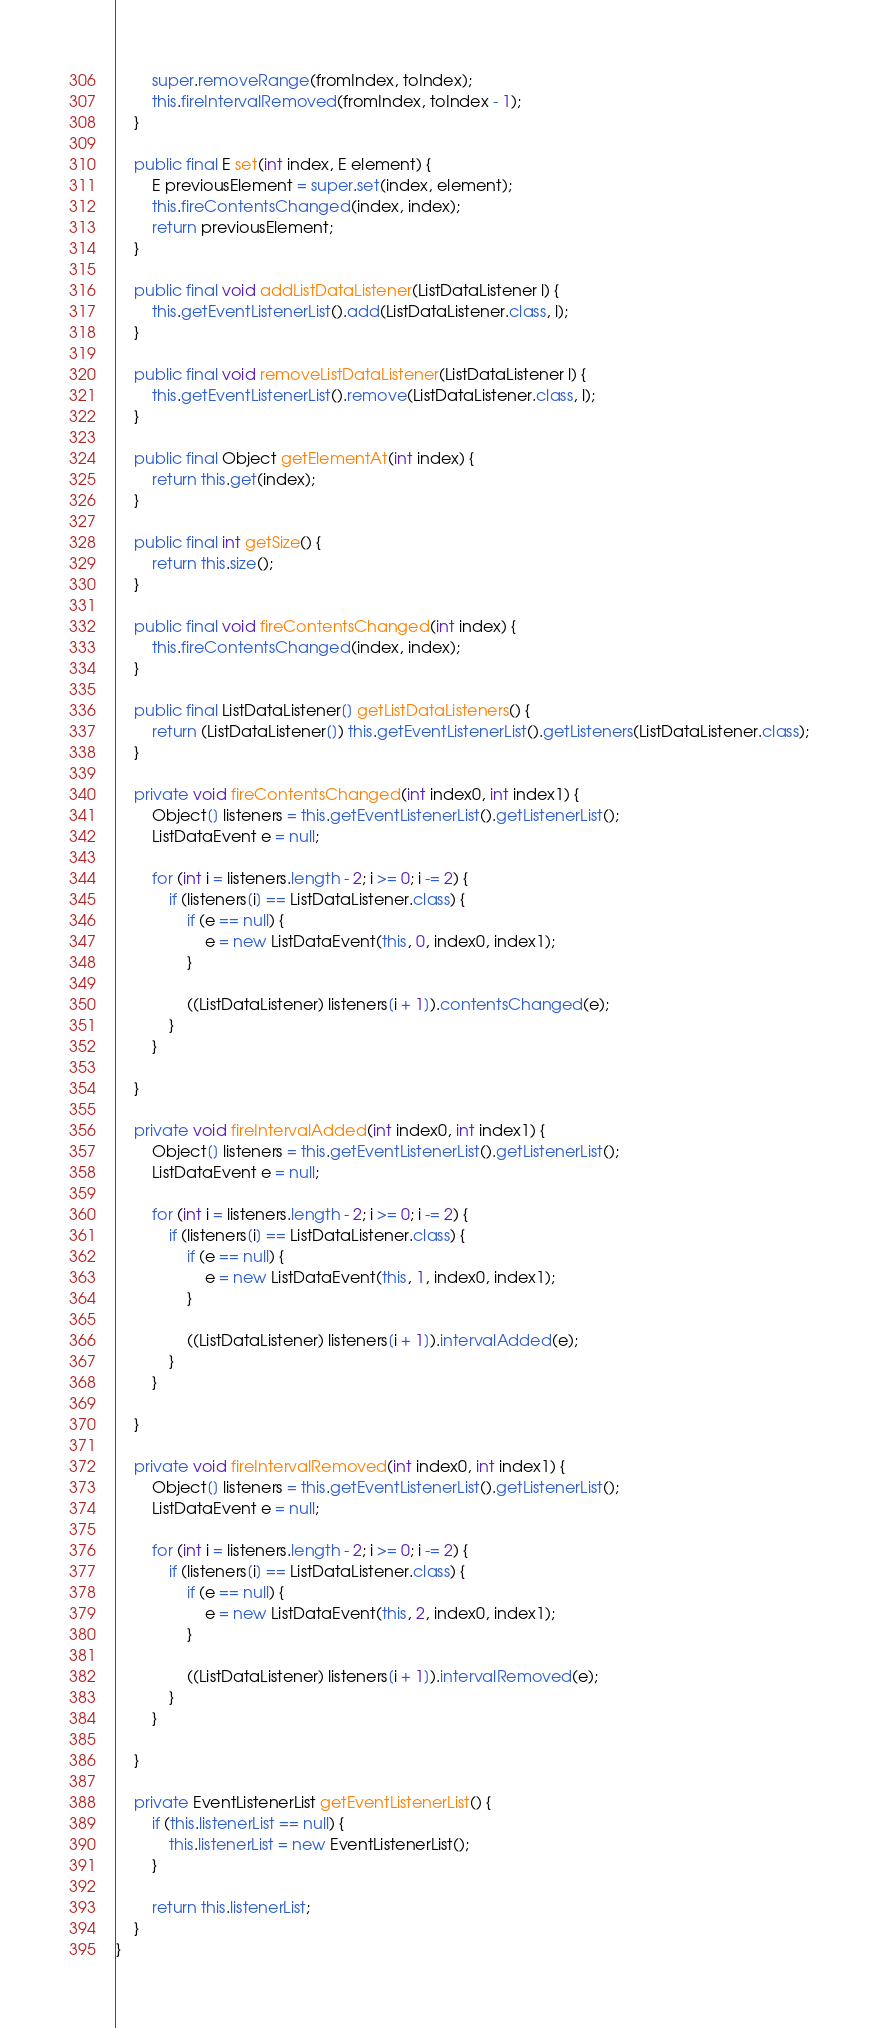<code> <loc_0><loc_0><loc_500><loc_500><_Java_>        super.removeRange(fromIndex, toIndex);
        this.fireIntervalRemoved(fromIndex, toIndex - 1);
    }

    public final E set(int index, E element) {
        E previousElement = super.set(index, element);
        this.fireContentsChanged(index, index);
        return previousElement;
    }

    public final void addListDataListener(ListDataListener l) {
        this.getEventListenerList().add(ListDataListener.class, l);
    }

    public final void removeListDataListener(ListDataListener l) {
        this.getEventListenerList().remove(ListDataListener.class, l);
    }

    public final Object getElementAt(int index) {
        return this.get(index);
    }

    public final int getSize() {
        return this.size();
    }

    public final void fireContentsChanged(int index) {
        this.fireContentsChanged(index, index);
    }

    public final ListDataListener[] getListDataListeners() {
        return (ListDataListener[]) this.getEventListenerList().getListeners(ListDataListener.class);
    }

    private void fireContentsChanged(int index0, int index1) {
        Object[] listeners = this.getEventListenerList().getListenerList();
        ListDataEvent e = null;

        for (int i = listeners.length - 2; i >= 0; i -= 2) {
            if (listeners[i] == ListDataListener.class) {
                if (e == null) {
                    e = new ListDataEvent(this, 0, index0, index1);
                }

                ((ListDataListener) listeners[i + 1]).contentsChanged(e);
            }
        }

    }

    private void fireIntervalAdded(int index0, int index1) {
        Object[] listeners = this.getEventListenerList().getListenerList();
        ListDataEvent e = null;

        for (int i = listeners.length - 2; i >= 0; i -= 2) {
            if (listeners[i] == ListDataListener.class) {
                if (e == null) {
                    e = new ListDataEvent(this, 1, index0, index1);
                }

                ((ListDataListener) listeners[i + 1]).intervalAdded(e);
            }
        }

    }

    private void fireIntervalRemoved(int index0, int index1) {
        Object[] listeners = this.getEventListenerList().getListenerList();
        ListDataEvent e = null;

        for (int i = listeners.length - 2; i >= 0; i -= 2) {
            if (listeners[i] == ListDataListener.class) {
                if (e == null) {
                    e = new ListDataEvent(this, 2, index0, index1);
                }

                ((ListDataListener) listeners[i + 1]).intervalRemoved(e);
            }
        }

    }

    private EventListenerList getEventListenerList() {
        if (this.listenerList == null) {
            this.listenerList = new EventListenerList();
        }

        return this.listenerList;
    }
}
</code> 